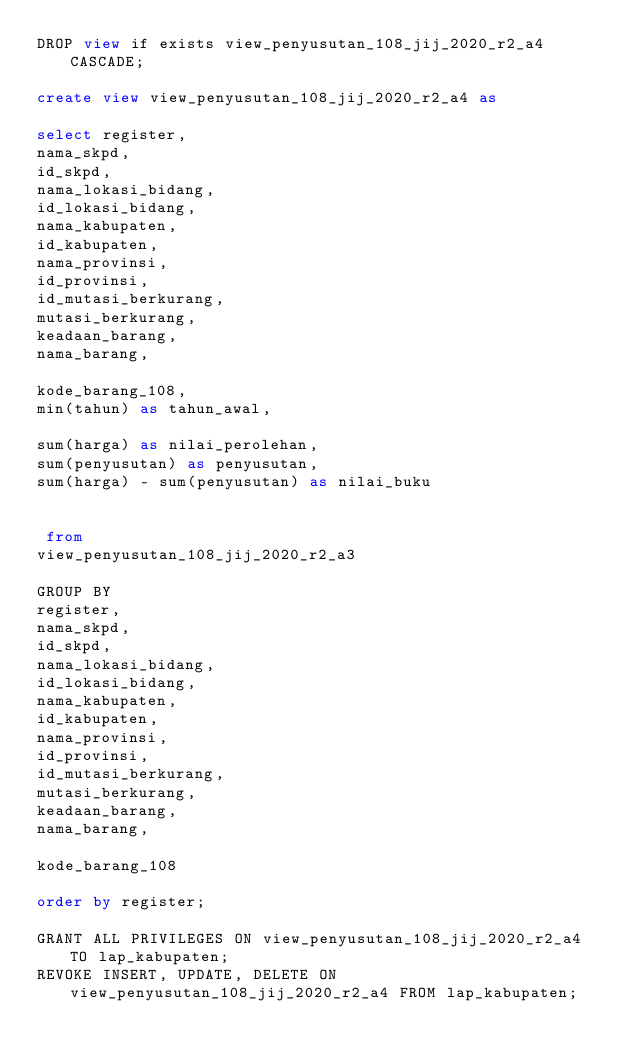<code> <loc_0><loc_0><loc_500><loc_500><_SQL_>DROP view if exists view_penyusutan_108_jij_2020_r2_a4 CASCADE;

create view view_penyusutan_108_jij_2020_r2_a4 as

select register,
nama_skpd,
id_skpd,
nama_lokasi_bidang,
id_lokasi_bidang,
nama_kabupaten,
id_kabupaten,
nama_provinsi,
id_provinsi,
id_mutasi_berkurang,
mutasi_berkurang,
keadaan_barang,
nama_barang,

kode_barang_108,
min(tahun) as tahun_awal,

sum(harga) as nilai_perolehan,
sum(penyusutan) as penyusutan,
sum(harga) - sum(penyusutan) as nilai_buku


 from
view_penyusutan_108_jij_2020_r2_a3

GROUP BY
register,
nama_skpd,
id_skpd,
nama_lokasi_bidang,
id_lokasi_bidang,
nama_kabupaten,
id_kabupaten,
nama_provinsi,
id_provinsi,
id_mutasi_berkurang,
mutasi_berkurang,
keadaan_barang,
nama_barang,

kode_barang_108

order by register;

GRANT ALL PRIVILEGES ON view_penyusutan_108_jij_2020_r2_a4 TO lap_kabupaten;
REVOKE INSERT, UPDATE, DELETE ON view_penyusutan_108_jij_2020_r2_a4 FROM lap_kabupaten;
</code> 